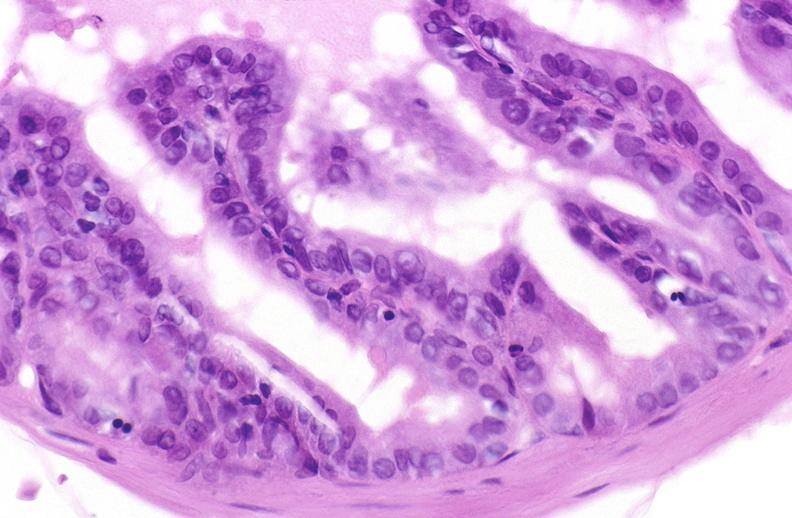does this image show apoptosis in prostate after orchiectomy?
Answer the question using a single word or phrase. Yes 